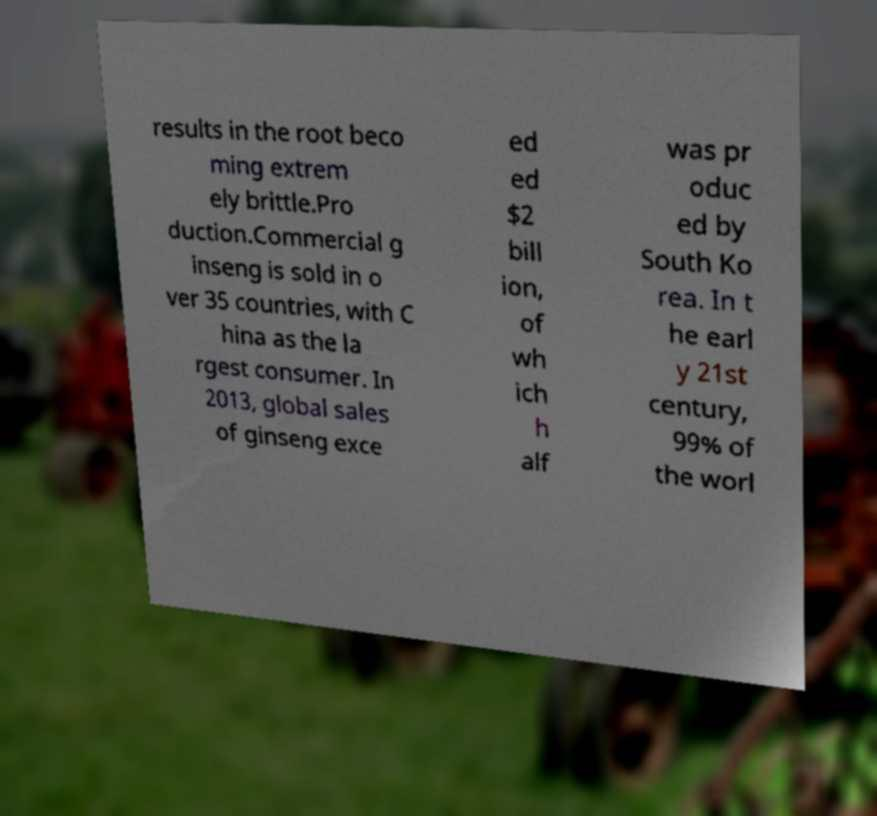For documentation purposes, I need the text within this image transcribed. Could you provide that? results in the root beco ming extrem ely brittle.Pro duction.Commercial g inseng is sold in o ver 35 countries, with C hina as the la rgest consumer. In 2013, global sales of ginseng exce ed ed $2 bill ion, of wh ich h alf was pr oduc ed by South Ko rea. In t he earl y 21st century, 99% of the worl 